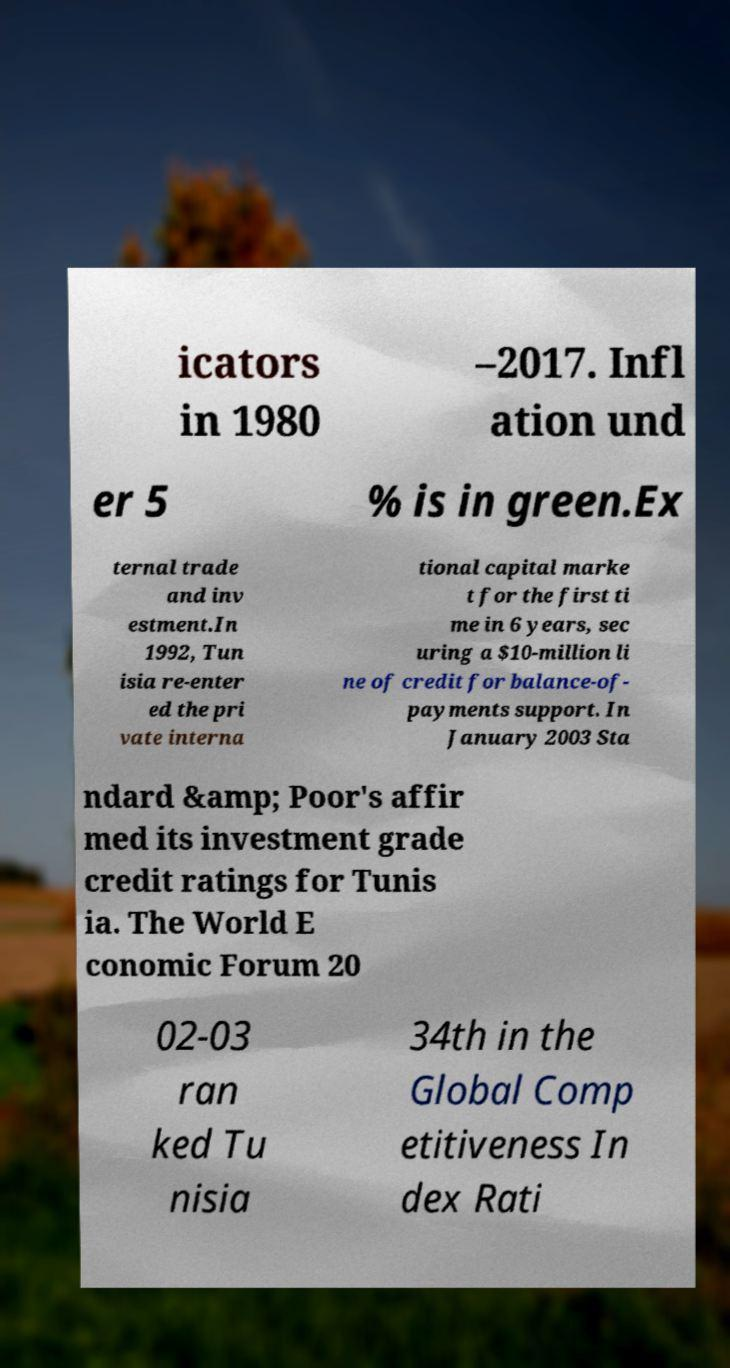Can you accurately transcribe the text from the provided image for me? icators in 1980 –2017. Infl ation und er 5 % is in green.Ex ternal trade and inv estment.In 1992, Tun isia re-enter ed the pri vate interna tional capital marke t for the first ti me in 6 years, sec uring a $10-million li ne of credit for balance-of- payments support. In January 2003 Sta ndard &amp; Poor's affir med its investment grade credit ratings for Tunis ia. The World E conomic Forum 20 02-03 ran ked Tu nisia 34th in the Global Comp etitiveness In dex Rati 